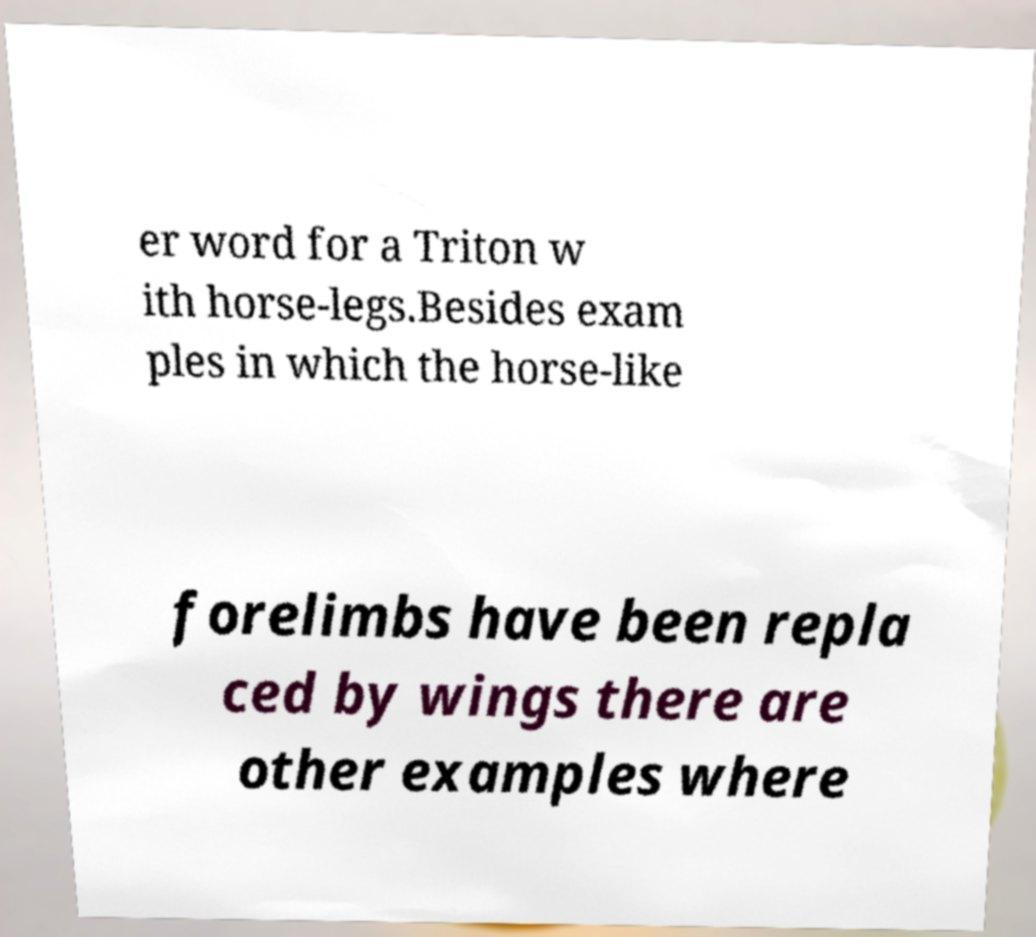I need the written content from this picture converted into text. Can you do that? er word for a Triton w ith horse-legs.Besides exam ples in which the horse-like forelimbs have been repla ced by wings there are other examples where 